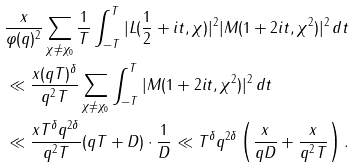Convert formula to latex. <formula><loc_0><loc_0><loc_500><loc_500>& \frac { x } { \varphi ( q ) ^ { 2 } } \sum _ { \chi \neq \chi _ { 0 } } \frac { 1 } { T } \int _ { - T } ^ { T } | L ( \frac { 1 } { 2 } + i t , \chi ) | ^ { 2 } | M ( 1 + 2 i t , \chi ^ { 2 } ) | ^ { 2 } \, d t \\ & \ll \frac { x ( q T ) ^ { \delta } } { q ^ { 2 } T } \sum _ { \chi \neq \chi _ { 0 } } \int _ { - T } ^ { T } | M ( 1 + 2 i t , \chi ^ { 2 } ) | ^ { 2 } \, d t \\ & \ll \frac { x T ^ { \delta } q ^ { 2 \delta } } { q ^ { 2 } T } ( q T + D ) \cdot \frac { 1 } { D } \ll T ^ { \delta } q ^ { 2 \delta } \left ( \frac { x } { q D } + \frac { x } { q ^ { 2 } T } \right ) .</formula> 